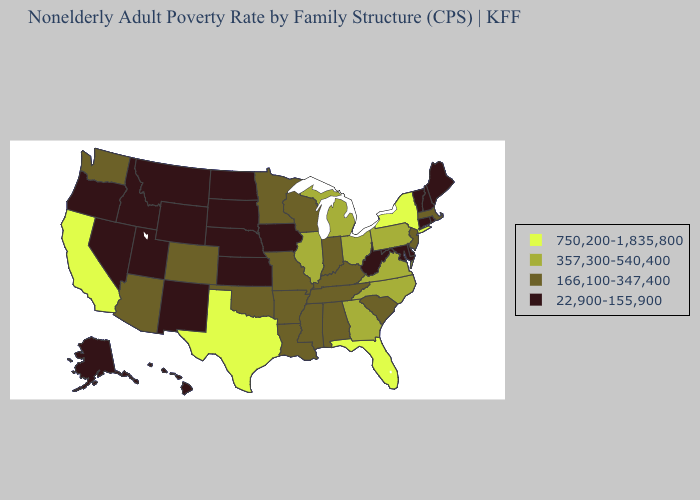Name the states that have a value in the range 750,200-1,835,800?
Answer briefly. California, Florida, New York, Texas. Which states have the lowest value in the South?
Be succinct. Delaware, Maryland, West Virginia. What is the value of Mississippi?
Write a very short answer. 166,100-347,400. Does South Dakota have the highest value in the USA?
Give a very brief answer. No. Among the states that border Minnesota , does Wisconsin have the highest value?
Quick response, please. Yes. Name the states that have a value in the range 22,900-155,900?
Keep it brief. Alaska, Connecticut, Delaware, Hawaii, Idaho, Iowa, Kansas, Maine, Maryland, Montana, Nebraska, Nevada, New Hampshire, New Mexico, North Dakota, Oregon, Rhode Island, South Dakota, Utah, Vermont, West Virginia, Wyoming. What is the lowest value in states that border Louisiana?
Keep it brief. 166,100-347,400. Does Michigan have a lower value than Oklahoma?
Quick response, please. No. Among the states that border California , which have the lowest value?
Short answer required. Nevada, Oregon. What is the value of Connecticut?
Write a very short answer. 22,900-155,900. Name the states that have a value in the range 166,100-347,400?
Quick response, please. Alabama, Arizona, Arkansas, Colorado, Indiana, Kentucky, Louisiana, Massachusetts, Minnesota, Mississippi, Missouri, New Jersey, Oklahoma, South Carolina, Tennessee, Washington, Wisconsin. Name the states that have a value in the range 357,300-540,400?
Short answer required. Georgia, Illinois, Michigan, North Carolina, Ohio, Pennsylvania, Virginia. Name the states that have a value in the range 357,300-540,400?
Short answer required. Georgia, Illinois, Michigan, North Carolina, Ohio, Pennsylvania, Virginia. Name the states that have a value in the range 357,300-540,400?
Write a very short answer. Georgia, Illinois, Michigan, North Carolina, Ohio, Pennsylvania, Virginia. What is the value of Rhode Island?
Short answer required. 22,900-155,900. 